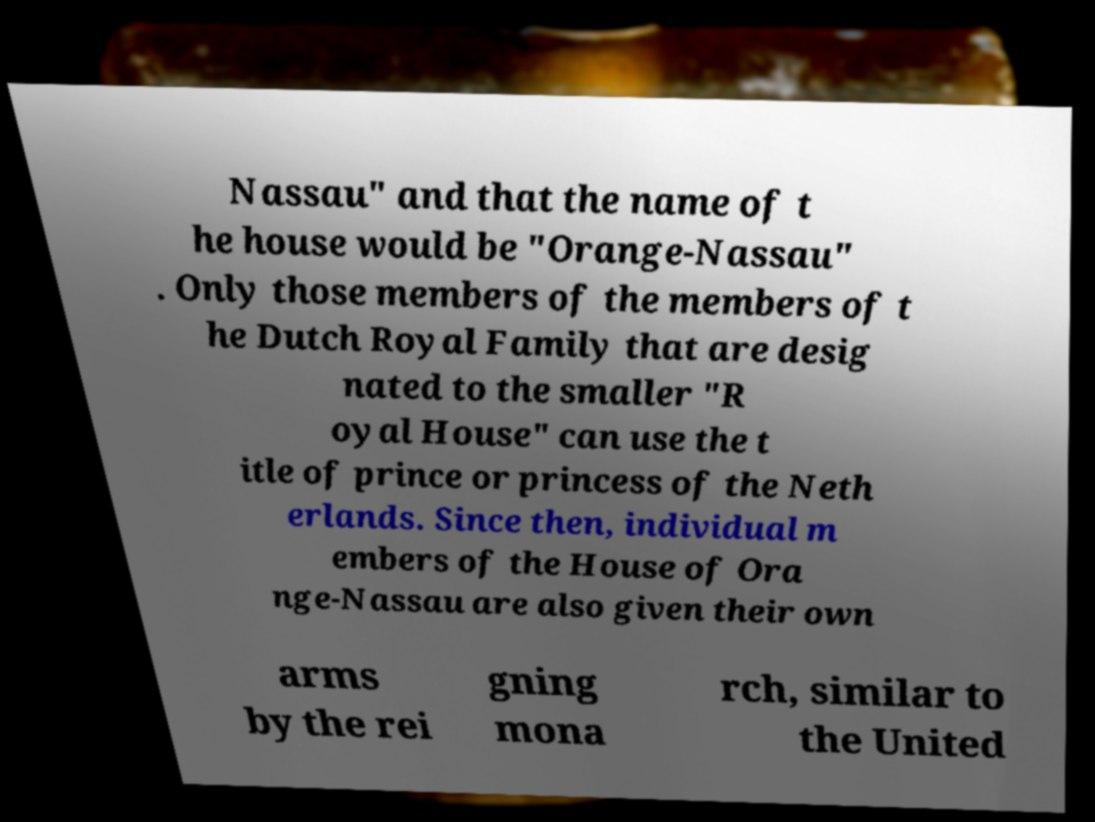Could you extract and type out the text from this image? Nassau" and that the name of t he house would be "Orange-Nassau" . Only those members of the members of t he Dutch Royal Family that are desig nated to the smaller "R oyal House" can use the t itle of prince or princess of the Neth erlands. Since then, individual m embers of the House of Ora nge-Nassau are also given their own arms by the rei gning mona rch, similar to the United 